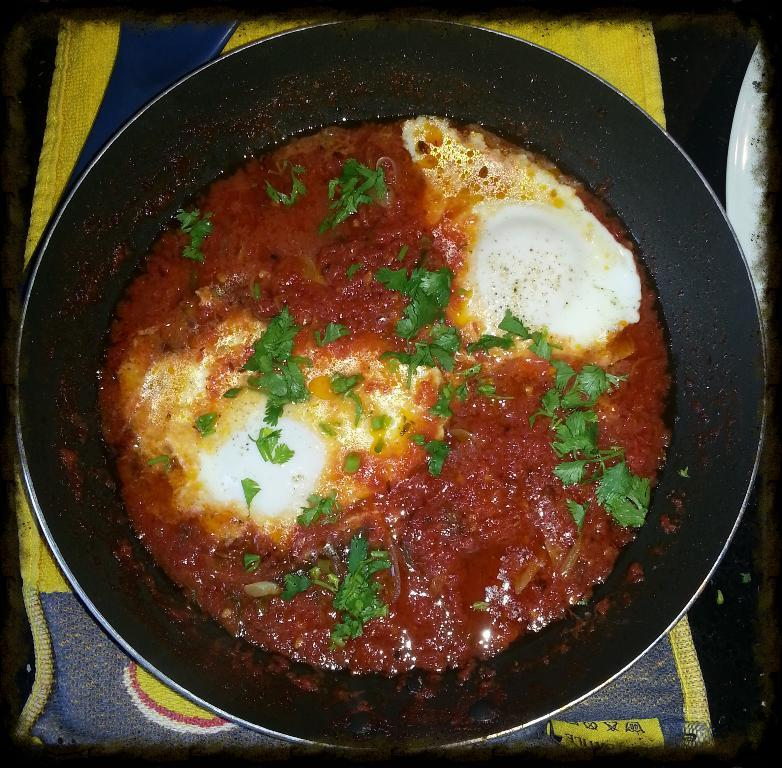What is the main subject of the image? There is a food item in the image. What is the color of the pan on which the food item is placed? The pan is black in color. How is the pan positioned in the image? The pan is placed on a napkin. What are the colors of the napkin? The napkin has blue and yellow colors. What other dishware can be seen in the image? There is a plate in the image. How many people are in the crowd surrounding the food item in the image? There is no crowd present in the image; it only shows a food item on a pan placed on a napkin. What type of corn is being served on the plate in the image? There is no corn present in the image; it only shows a food item on a pan placed on a napkin and a plate. 